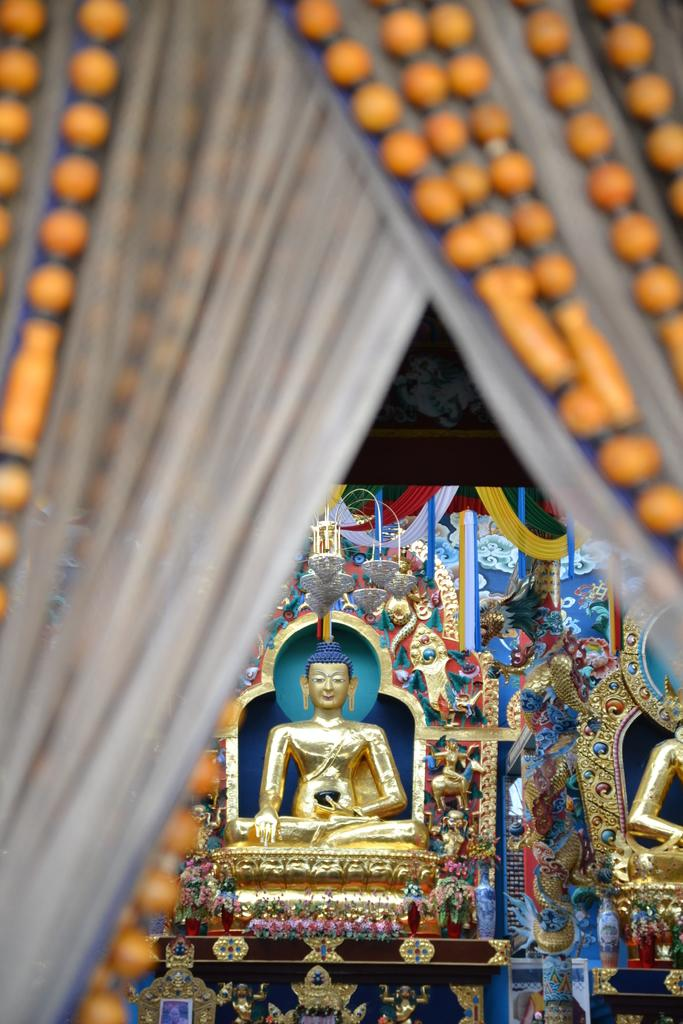What is located at the front of the image? There is a curtain in the front of the image. What can be seen in the background of the image? There is a statue and decorative things in the background of the image. What type of wire is holding the statue in place in the image? There is no wire visible in the image, and the statue's support is not mentioned in the provided facts. What color is the patch on the curtain in the image? There is no mention of a patch on the curtain in the provided facts. 